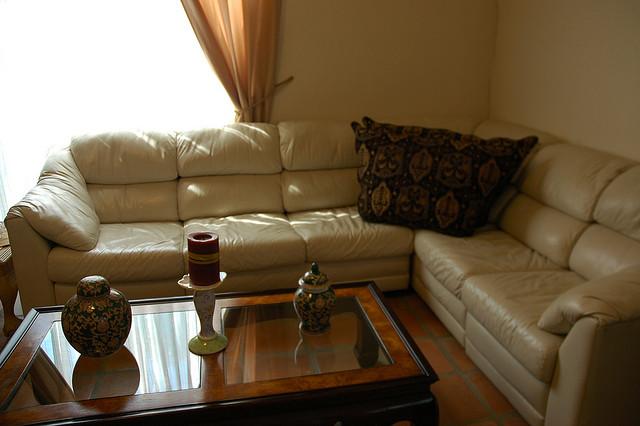What is the main color in this photo?
Concise answer only. Tan. How many pillows are on the couch?
Short answer required. 2. How many couches are here?
Short answer required. 1. 